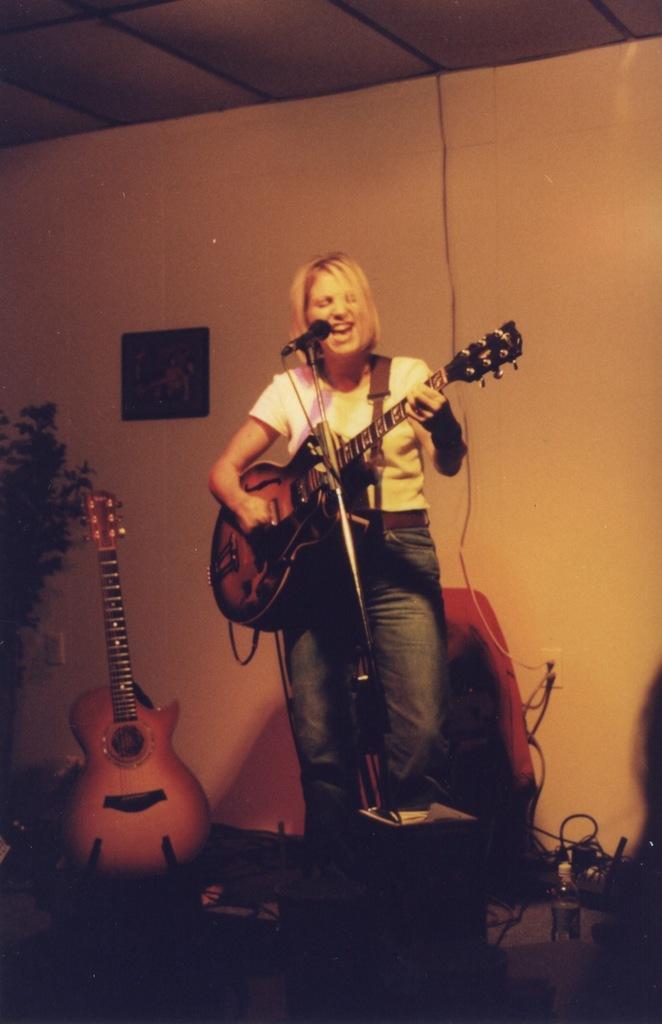Could you give a brief overview of what you see in this image? This is a woman standing and playing guitar. She is singing a song in the mike. I can see another guitar placed beside her. At background I can see a photo frame attached to the wall and this looks like a house plant. 